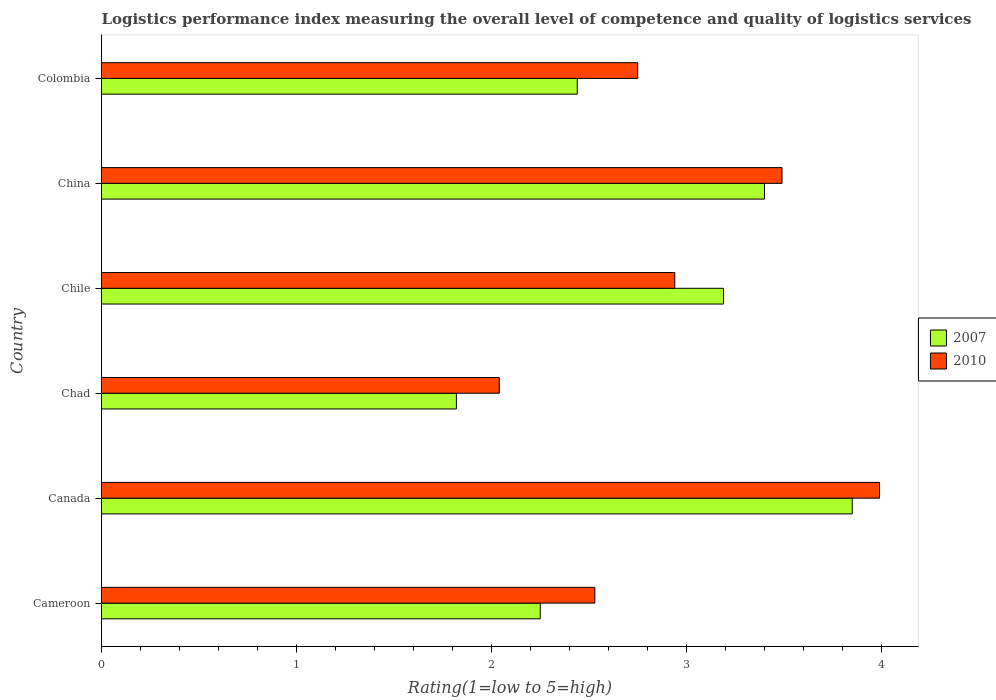Are the number of bars per tick equal to the number of legend labels?
Your answer should be very brief. Yes. What is the label of the 2nd group of bars from the top?
Your answer should be very brief. China. In how many cases, is the number of bars for a given country not equal to the number of legend labels?
Provide a succinct answer. 0. What is the Logistic performance index in 2010 in Cameroon?
Provide a succinct answer. 2.53. Across all countries, what is the maximum Logistic performance index in 2007?
Provide a succinct answer. 3.85. Across all countries, what is the minimum Logistic performance index in 2010?
Provide a short and direct response. 2.04. In which country was the Logistic performance index in 2010 maximum?
Your answer should be compact. Canada. In which country was the Logistic performance index in 2007 minimum?
Make the answer very short. Chad. What is the total Logistic performance index in 2007 in the graph?
Provide a short and direct response. 16.95. What is the difference between the Logistic performance index in 2007 in Chile and that in Colombia?
Make the answer very short. 0.75. What is the difference between the Logistic performance index in 2007 in Chad and the Logistic performance index in 2010 in Colombia?
Offer a terse response. -0.93. What is the average Logistic performance index in 2010 per country?
Offer a terse response. 2.96. What is the difference between the Logistic performance index in 2010 and Logistic performance index in 2007 in Cameroon?
Give a very brief answer. 0.28. In how many countries, is the Logistic performance index in 2010 greater than 0.8 ?
Your answer should be compact. 6. What is the ratio of the Logistic performance index in 2010 in Chad to that in China?
Give a very brief answer. 0.58. Is the Logistic performance index in 2010 in Chile less than that in China?
Provide a succinct answer. Yes. What is the difference between the highest and the second highest Logistic performance index in 2007?
Keep it short and to the point. 0.45. What is the difference between the highest and the lowest Logistic performance index in 2007?
Your response must be concise. 2.03. In how many countries, is the Logistic performance index in 2010 greater than the average Logistic performance index in 2010 taken over all countries?
Make the answer very short. 2. Is the sum of the Logistic performance index in 2010 in Canada and China greater than the maximum Logistic performance index in 2007 across all countries?
Keep it short and to the point. Yes. What does the 2nd bar from the top in Colombia represents?
Keep it short and to the point. 2007. What does the 1st bar from the bottom in Chile represents?
Provide a succinct answer. 2007. How many bars are there?
Provide a succinct answer. 12. Does the graph contain any zero values?
Offer a terse response. No. Where does the legend appear in the graph?
Ensure brevity in your answer.  Center right. What is the title of the graph?
Offer a terse response. Logistics performance index measuring the overall level of competence and quality of logistics services. What is the label or title of the X-axis?
Your answer should be compact. Rating(1=low to 5=high). What is the label or title of the Y-axis?
Provide a succinct answer. Country. What is the Rating(1=low to 5=high) in 2007 in Cameroon?
Provide a succinct answer. 2.25. What is the Rating(1=low to 5=high) of 2010 in Cameroon?
Keep it short and to the point. 2.53. What is the Rating(1=low to 5=high) in 2007 in Canada?
Give a very brief answer. 3.85. What is the Rating(1=low to 5=high) in 2010 in Canada?
Provide a short and direct response. 3.99. What is the Rating(1=low to 5=high) of 2007 in Chad?
Offer a terse response. 1.82. What is the Rating(1=low to 5=high) in 2010 in Chad?
Provide a succinct answer. 2.04. What is the Rating(1=low to 5=high) in 2007 in Chile?
Provide a short and direct response. 3.19. What is the Rating(1=low to 5=high) of 2010 in Chile?
Offer a very short reply. 2.94. What is the Rating(1=low to 5=high) in 2007 in China?
Your answer should be compact. 3.4. What is the Rating(1=low to 5=high) in 2010 in China?
Make the answer very short. 3.49. What is the Rating(1=low to 5=high) of 2007 in Colombia?
Your answer should be compact. 2.44. What is the Rating(1=low to 5=high) of 2010 in Colombia?
Your answer should be compact. 2.75. Across all countries, what is the maximum Rating(1=low to 5=high) in 2007?
Your answer should be very brief. 3.85. Across all countries, what is the maximum Rating(1=low to 5=high) in 2010?
Provide a short and direct response. 3.99. Across all countries, what is the minimum Rating(1=low to 5=high) in 2007?
Offer a very short reply. 1.82. Across all countries, what is the minimum Rating(1=low to 5=high) in 2010?
Your response must be concise. 2.04. What is the total Rating(1=low to 5=high) in 2007 in the graph?
Ensure brevity in your answer.  16.95. What is the total Rating(1=low to 5=high) in 2010 in the graph?
Offer a very short reply. 17.74. What is the difference between the Rating(1=low to 5=high) of 2010 in Cameroon and that in Canada?
Your response must be concise. -1.46. What is the difference between the Rating(1=low to 5=high) in 2007 in Cameroon and that in Chad?
Keep it short and to the point. 0.43. What is the difference between the Rating(1=low to 5=high) in 2010 in Cameroon and that in Chad?
Provide a succinct answer. 0.49. What is the difference between the Rating(1=low to 5=high) in 2007 in Cameroon and that in Chile?
Provide a short and direct response. -0.94. What is the difference between the Rating(1=low to 5=high) in 2010 in Cameroon and that in Chile?
Your answer should be compact. -0.41. What is the difference between the Rating(1=low to 5=high) in 2007 in Cameroon and that in China?
Keep it short and to the point. -1.15. What is the difference between the Rating(1=low to 5=high) in 2010 in Cameroon and that in China?
Your answer should be compact. -0.96. What is the difference between the Rating(1=low to 5=high) of 2007 in Cameroon and that in Colombia?
Provide a short and direct response. -0.19. What is the difference between the Rating(1=low to 5=high) of 2010 in Cameroon and that in Colombia?
Offer a terse response. -0.22. What is the difference between the Rating(1=low to 5=high) of 2007 in Canada and that in Chad?
Make the answer very short. 2.03. What is the difference between the Rating(1=low to 5=high) in 2010 in Canada and that in Chad?
Offer a terse response. 1.95. What is the difference between the Rating(1=low to 5=high) in 2007 in Canada and that in Chile?
Provide a short and direct response. 0.66. What is the difference between the Rating(1=low to 5=high) in 2010 in Canada and that in Chile?
Provide a succinct answer. 1.05. What is the difference between the Rating(1=low to 5=high) in 2007 in Canada and that in China?
Your answer should be compact. 0.45. What is the difference between the Rating(1=low to 5=high) of 2007 in Canada and that in Colombia?
Offer a very short reply. 1.41. What is the difference between the Rating(1=low to 5=high) of 2010 in Canada and that in Colombia?
Keep it short and to the point. 1.24. What is the difference between the Rating(1=low to 5=high) of 2007 in Chad and that in Chile?
Give a very brief answer. -1.37. What is the difference between the Rating(1=low to 5=high) of 2007 in Chad and that in China?
Offer a terse response. -1.58. What is the difference between the Rating(1=low to 5=high) in 2010 in Chad and that in China?
Your response must be concise. -1.45. What is the difference between the Rating(1=low to 5=high) in 2007 in Chad and that in Colombia?
Offer a terse response. -0.62. What is the difference between the Rating(1=low to 5=high) in 2010 in Chad and that in Colombia?
Keep it short and to the point. -0.71. What is the difference between the Rating(1=low to 5=high) of 2007 in Chile and that in China?
Keep it short and to the point. -0.21. What is the difference between the Rating(1=low to 5=high) of 2010 in Chile and that in China?
Ensure brevity in your answer.  -0.55. What is the difference between the Rating(1=low to 5=high) in 2010 in Chile and that in Colombia?
Keep it short and to the point. 0.19. What is the difference between the Rating(1=low to 5=high) of 2010 in China and that in Colombia?
Provide a succinct answer. 0.74. What is the difference between the Rating(1=low to 5=high) in 2007 in Cameroon and the Rating(1=low to 5=high) in 2010 in Canada?
Make the answer very short. -1.74. What is the difference between the Rating(1=low to 5=high) of 2007 in Cameroon and the Rating(1=low to 5=high) of 2010 in Chad?
Your answer should be compact. 0.21. What is the difference between the Rating(1=low to 5=high) in 2007 in Cameroon and the Rating(1=low to 5=high) in 2010 in Chile?
Make the answer very short. -0.69. What is the difference between the Rating(1=low to 5=high) in 2007 in Cameroon and the Rating(1=low to 5=high) in 2010 in China?
Provide a short and direct response. -1.24. What is the difference between the Rating(1=low to 5=high) in 2007 in Cameroon and the Rating(1=low to 5=high) in 2010 in Colombia?
Provide a short and direct response. -0.5. What is the difference between the Rating(1=low to 5=high) of 2007 in Canada and the Rating(1=low to 5=high) of 2010 in Chad?
Offer a terse response. 1.81. What is the difference between the Rating(1=low to 5=high) in 2007 in Canada and the Rating(1=low to 5=high) in 2010 in Chile?
Offer a terse response. 0.91. What is the difference between the Rating(1=low to 5=high) in 2007 in Canada and the Rating(1=low to 5=high) in 2010 in China?
Keep it short and to the point. 0.36. What is the difference between the Rating(1=low to 5=high) of 2007 in Canada and the Rating(1=low to 5=high) of 2010 in Colombia?
Offer a very short reply. 1.1. What is the difference between the Rating(1=low to 5=high) in 2007 in Chad and the Rating(1=low to 5=high) in 2010 in Chile?
Offer a terse response. -1.12. What is the difference between the Rating(1=low to 5=high) in 2007 in Chad and the Rating(1=low to 5=high) in 2010 in China?
Make the answer very short. -1.67. What is the difference between the Rating(1=low to 5=high) of 2007 in Chad and the Rating(1=low to 5=high) of 2010 in Colombia?
Provide a short and direct response. -0.93. What is the difference between the Rating(1=low to 5=high) of 2007 in Chile and the Rating(1=low to 5=high) of 2010 in China?
Offer a very short reply. -0.3. What is the difference between the Rating(1=low to 5=high) of 2007 in Chile and the Rating(1=low to 5=high) of 2010 in Colombia?
Offer a very short reply. 0.44. What is the difference between the Rating(1=low to 5=high) in 2007 in China and the Rating(1=low to 5=high) in 2010 in Colombia?
Give a very brief answer. 0.65. What is the average Rating(1=low to 5=high) in 2007 per country?
Make the answer very short. 2.83. What is the average Rating(1=low to 5=high) of 2010 per country?
Offer a very short reply. 2.96. What is the difference between the Rating(1=low to 5=high) of 2007 and Rating(1=low to 5=high) of 2010 in Cameroon?
Make the answer very short. -0.28. What is the difference between the Rating(1=low to 5=high) of 2007 and Rating(1=low to 5=high) of 2010 in Canada?
Your response must be concise. -0.14. What is the difference between the Rating(1=low to 5=high) in 2007 and Rating(1=low to 5=high) in 2010 in Chad?
Make the answer very short. -0.22. What is the difference between the Rating(1=low to 5=high) in 2007 and Rating(1=low to 5=high) in 2010 in Chile?
Provide a short and direct response. 0.25. What is the difference between the Rating(1=low to 5=high) in 2007 and Rating(1=low to 5=high) in 2010 in China?
Your answer should be very brief. -0.09. What is the difference between the Rating(1=low to 5=high) in 2007 and Rating(1=low to 5=high) in 2010 in Colombia?
Give a very brief answer. -0.31. What is the ratio of the Rating(1=low to 5=high) in 2007 in Cameroon to that in Canada?
Offer a very short reply. 0.58. What is the ratio of the Rating(1=low to 5=high) in 2010 in Cameroon to that in Canada?
Offer a terse response. 0.63. What is the ratio of the Rating(1=low to 5=high) of 2007 in Cameroon to that in Chad?
Your answer should be very brief. 1.24. What is the ratio of the Rating(1=low to 5=high) of 2010 in Cameroon to that in Chad?
Offer a very short reply. 1.24. What is the ratio of the Rating(1=low to 5=high) in 2007 in Cameroon to that in Chile?
Your answer should be very brief. 0.71. What is the ratio of the Rating(1=low to 5=high) of 2010 in Cameroon to that in Chile?
Offer a terse response. 0.86. What is the ratio of the Rating(1=low to 5=high) of 2007 in Cameroon to that in China?
Ensure brevity in your answer.  0.66. What is the ratio of the Rating(1=low to 5=high) in 2010 in Cameroon to that in China?
Keep it short and to the point. 0.72. What is the ratio of the Rating(1=low to 5=high) in 2007 in Cameroon to that in Colombia?
Provide a succinct answer. 0.92. What is the ratio of the Rating(1=low to 5=high) in 2007 in Canada to that in Chad?
Offer a very short reply. 2.12. What is the ratio of the Rating(1=low to 5=high) in 2010 in Canada to that in Chad?
Your response must be concise. 1.96. What is the ratio of the Rating(1=low to 5=high) in 2007 in Canada to that in Chile?
Provide a short and direct response. 1.21. What is the ratio of the Rating(1=low to 5=high) of 2010 in Canada to that in Chile?
Provide a succinct answer. 1.36. What is the ratio of the Rating(1=low to 5=high) in 2007 in Canada to that in China?
Your answer should be compact. 1.13. What is the ratio of the Rating(1=low to 5=high) in 2010 in Canada to that in China?
Provide a short and direct response. 1.14. What is the ratio of the Rating(1=low to 5=high) in 2007 in Canada to that in Colombia?
Provide a short and direct response. 1.58. What is the ratio of the Rating(1=low to 5=high) in 2010 in Canada to that in Colombia?
Give a very brief answer. 1.45. What is the ratio of the Rating(1=low to 5=high) of 2007 in Chad to that in Chile?
Offer a terse response. 0.57. What is the ratio of the Rating(1=low to 5=high) of 2010 in Chad to that in Chile?
Your response must be concise. 0.69. What is the ratio of the Rating(1=low to 5=high) in 2007 in Chad to that in China?
Make the answer very short. 0.54. What is the ratio of the Rating(1=low to 5=high) in 2010 in Chad to that in China?
Give a very brief answer. 0.58. What is the ratio of the Rating(1=low to 5=high) of 2007 in Chad to that in Colombia?
Offer a very short reply. 0.75. What is the ratio of the Rating(1=low to 5=high) in 2010 in Chad to that in Colombia?
Your response must be concise. 0.74. What is the ratio of the Rating(1=low to 5=high) of 2007 in Chile to that in China?
Ensure brevity in your answer.  0.94. What is the ratio of the Rating(1=low to 5=high) in 2010 in Chile to that in China?
Your answer should be very brief. 0.84. What is the ratio of the Rating(1=low to 5=high) of 2007 in Chile to that in Colombia?
Provide a short and direct response. 1.31. What is the ratio of the Rating(1=low to 5=high) of 2010 in Chile to that in Colombia?
Offer a very short reply. 1.07. What is the ratio of the Rating(1=low to 5=high) of 2007 in China to that in Colombia?
Offer a terse response. 1.39. What is the ratio of the Rating(1=low to 5=high) of 2010 in China to that in Colombia?
Your answer should be very brief. 1.27. What is the difference between the highest and the second highest Rating(1=low to 5=high) in 2007?
Offer a very short reply. 0.45. What is the difference between the highest and the second highest Rating(1=low to 5=high) of 2010?
Offer a very short reply. 0.5. What is the difference between the highest and the lowest Rating(1=low to 5=high) of 2007?
Your answer should be compact. 2.03. What is the difference between the highest and the lowest Rating(1=low to 5=high) in 2010?
Your answer should be very brief. 1.95. 